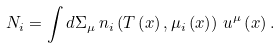Convert formula to latex. <formula><loc_0><loc_0><loc_500><loc_500>N _ { i } = \int d \Sigma _ { \mu } \, n _ { i } \left ( T \left ( x \right ) , \mu _ { i } \left ( x \right ) \right ) \, u ^ { \mu } \left ( x \right ) .</formula> 